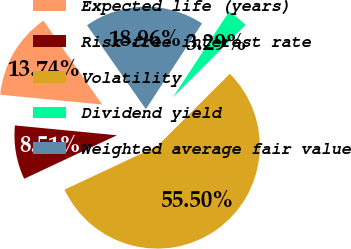Convert chart. <chart><loc_0><loc_0><loc_500><loc_500><pie_chart><fcel>Expected life (years)<fcel>Risk-free interest rate<fcel>Volatility<fcel>Dividend yield<fcel>Weighted average fair value<nl><fcel>13.74%<fcel>8.51%<fcel>55.5%<fcel>3.29%<fcel>18.96%<nl></chart> 